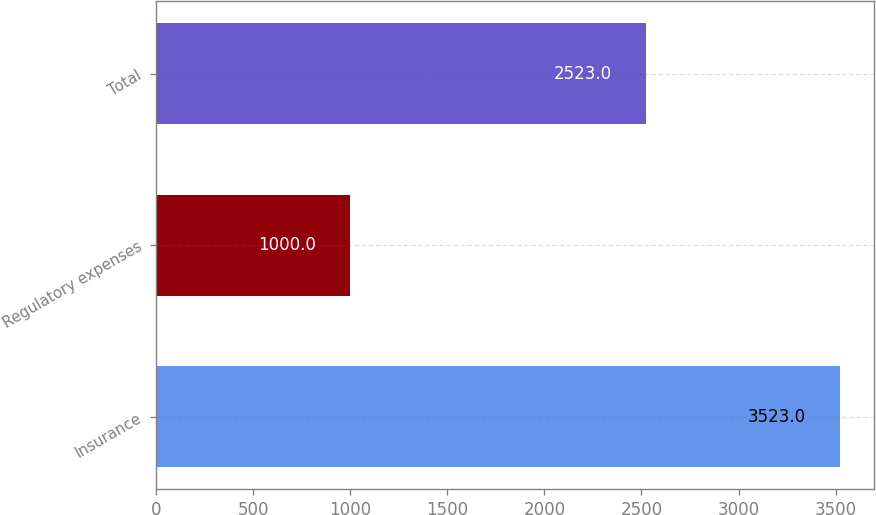<chart> <loc_0><loc_0><loc_500><loc_500><bar_chart><fcel>Insurance<fcel>Regulatory expenses<fcel>Total<nl><fcel>3523<fcel>1000<fcel>2523<nl></chart> 